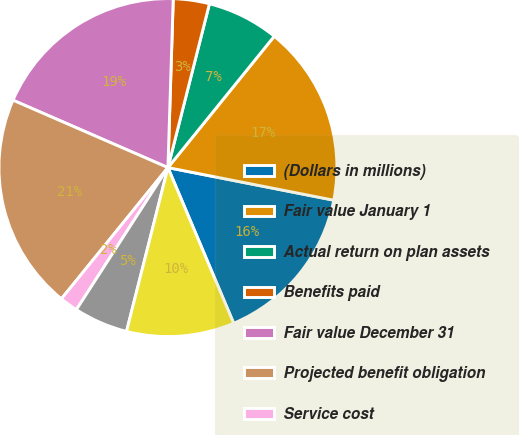<chart> <loc_0><loc_0><loc_500><loc_500><pie_chart><fcel>(Dollars in millions)<fcel>Fair value January 1<fcel>Actual return on plan assets<fcel>Benefits paid<fcel>Fair value December 31<fcel>Projected benefit obligation<fcel>Service cost<fcel>Interest cost<fcel>Actuarial loss (gain)<nl><fcel>15.55%<fcel>17.26%<fcel>6.88%<fcel>3.45%<fcel>18.97%<fcel>20.68%<fcel>1.74%<fcel>5.17%<fcel>10.3%<nl></chart> 